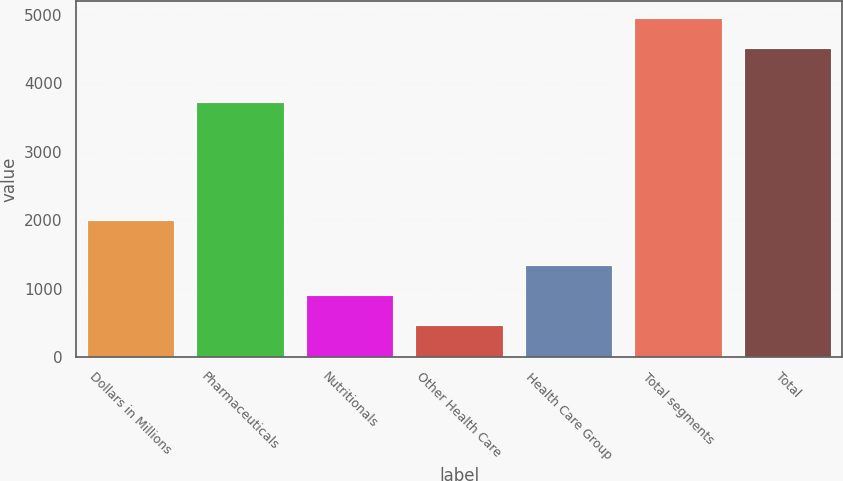<chart> <loc_0><loc_0><loc_500><loc_500><bar_chart><fcel>Dollars in Millions<fcel>Pharmaceuticals<fcel>Nutritionals<fcel>Other Health Care<fcel>Health Care Group<fcel>Total segments<fcel>Total<nl><fcel>2005<fcel>3732<fcel>909.9<fcel>469<fcel>1350.8<fcel>4956.9<fcel>4516<nl></chart> 